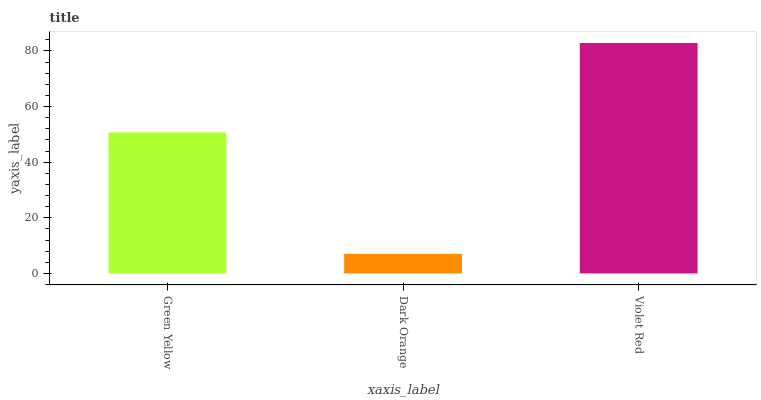Is Dark Orange the minimum?
Answer yes or no. Yes. Is Violet Red the maximum?
Answer yes or no. Yes. Is Violet Red the minimum?
Answer yes or no. No. Is Dark Orange the maximum?
Answer yes or no. No. Is Violet Red greater than Dark Orange?
Answer yes or no. Yes. Is Dark Orange less than Violet Red?
Answer yes or no. Yes. Is Dark Orange greater than Violet Red?
Answer yes or no. No. Is Violet Red less than Dark Orange?
Answer yes or no. No. Is Green Yellow the high median?
Answer yes or no. Yes. Is Green Yellow the low median?
Answer yes or no. Yes. Is Violet Red the high median?
Answer yes or no. No. Is Dark Orange the low median?
Answer yes or no. No. 